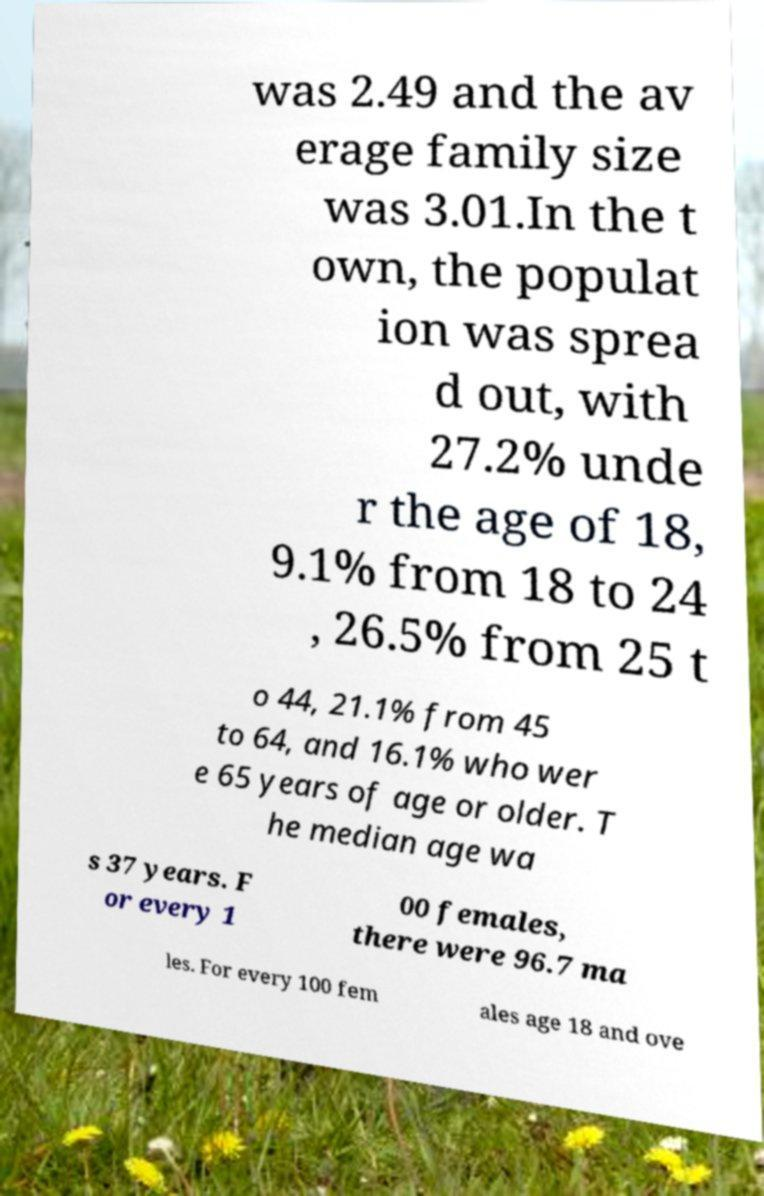There's text embedded in this image that I need extracted. Can you transcribe it verbatim? was 2.49 and the av erage family size was 3.01.In the t own, the populat ion was sprea d out, with 27.2% unde r the age of 18, 9.1% from 18 to 24 , 26.5% from 25 t o 44, 21.1% from 45 to 64, and 16.1% who wer e 65 years of age or older. T he median age wa s 37 years. F or every 1 00 females, there were 96.7 ma les. For every 100 fem ales age 18 and ove 